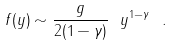<formula> <loc_0><loc_0><loc_500><loc_500>f ( y ) \sim \frac { g } { 2 ( 1 - \gamma ) } \ y ^ { 1 - \gamma } \ .</formula> 